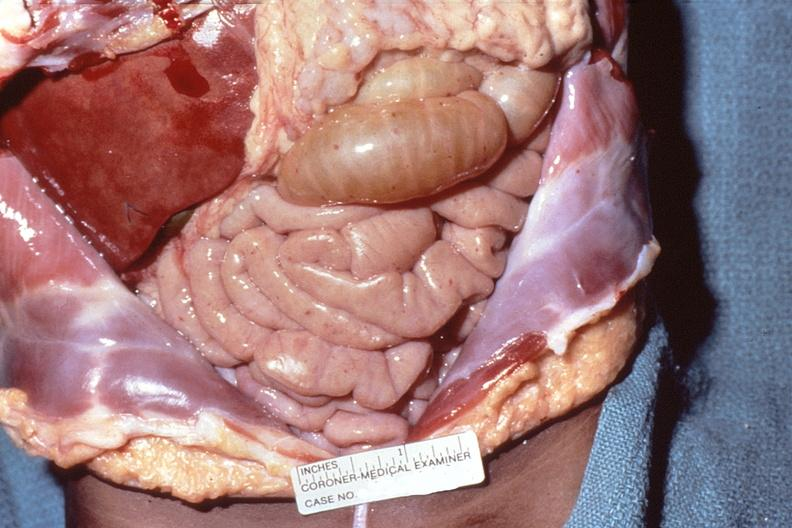what does this image show?
Answer the question using a single word or phrase. Meningococcemia 